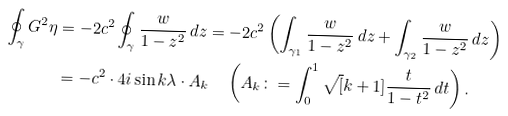Convert formula to latex. <formula><loc_0><loc_0><loc_500><loc_500>\oint _ { \gamma } G ^ { 2 } \eta & = - 2 c ^ { 2 } \oint _ { \gamma } \frac { w } { 1 - z ^ { 2 } } \, d z = - 2 c ^ { 2 } \left ( \int _ { \gamma _ { 1 } } \frac { w } { 1 - z ^ { 2 } } \, d z + \int _ { \gamma _ { 2 } } \frac { w } { 1 - z ^ { 2 } } \, d z \right ) \\ & = - c ^ { 2 } \cdot 4 i \sin k \lambda \cdot A _ { k } \quad \left ( A _ { k } \colon = \int _ { 0 } ^ { 1 } \sqrt { [ } k + 1 ] { \frac { t } { 1 - t ^ { 2 } } } \, d t \right ) .</formula> 